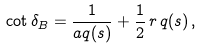<formula> <loc_0><loc_0><loc_500><loc_500>\cot { \delta _ { B } } = \frac { 1 } { a q ( s ) } + \frac { 1 } { 2 } \, r \, q ( s ) \, ,</formula> 